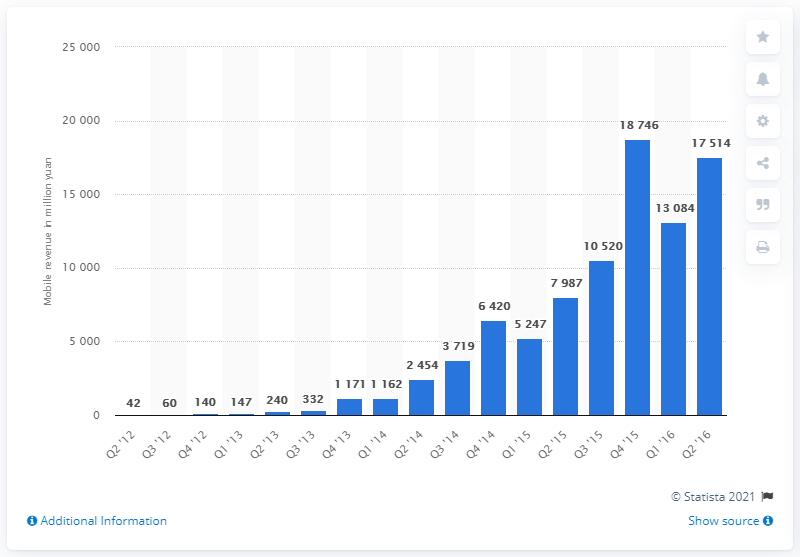Identify some key points in this picture. In the second quarter of 2016, Alibaba's mobile shopping revenue was 175.14 billion yuan. 